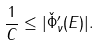<formula> <loc_0><loc_0><loc_500><loc_500>\frac { 1 } { C } \leq | \check { \Phi } _ { \nu } ^ { \prime } ( E ) | .</formula> 